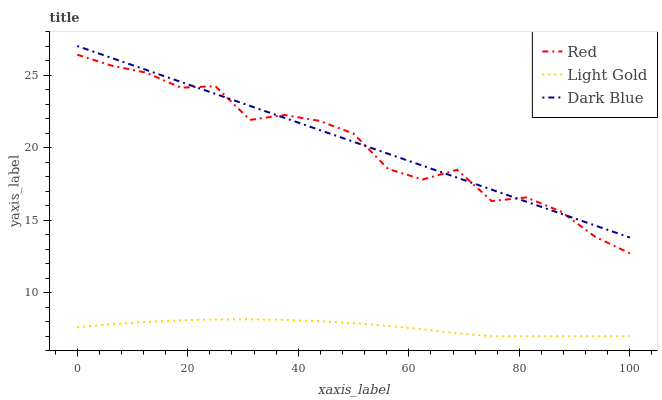Does Light Gold have the minimum area under the curve?
Answer yes or no. Yes. Does Dark Blue have the maximum area under the curve?
Answer yes or no. Yes. Does Red have the minimum area under the curve?
Answer yes or no. No. Does Red have the maximum area under the curve?
Answer yes or no. No. Is Dark Blue the smoothest?
Answer yes or no. Yes. Is Red the roughest?
Answer yes or no. Yes. Is Light Gold the smoothest?
Answer yes or no. No. Is Light Gold the roughest?
Answer yes or no. No. Does Light Gold have the lowest value?
Answer yes or no. Yes. Does Red have the lowest value?
Answer yes or no. No. Does Dark Blue have the highest value?
Answer yes or no. Yes. Does Red have the highest value?
Answer yes or no. No. Is Light Gold less than Dark Blue?
Answer yes or no. Yes. Is Red greater than Light Gold?
Answer yes or no. Yes. Does Red intersect Dark Blue?
Answer yes or no. Yes. Is Red less than Dark Blue?
Answer yes or no. No. Is Red greater than Dark Blue?
Answer yes or no. No. Does Light Gold intersect Dark Blue?
Answer yes or no. No. 